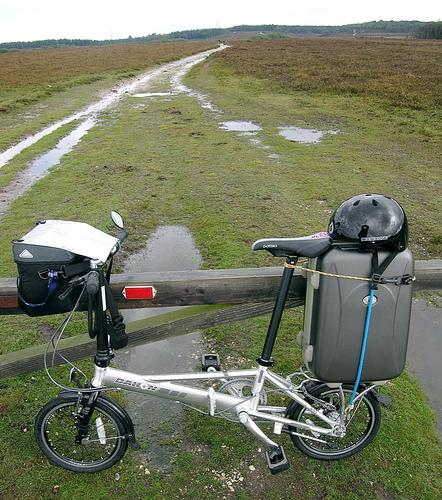Count how many bike wheels are present in the image and describe their positions. There are two bike wheels, the front wheel on the left and the back wheel on the right. Describe the image's sentiment or emotion. The image conveys a sense of wet, outdoor environment where one might have cycled on a rainy day and stopped to rest or park their bike. What type of helmet is on the bike, and where is it located? A black bike helmet rests on top of the bike, near its handlebars. What kind of fence is surrounding the bike, and what is the condition of the grass? It's a wooden fence, and the grass on the ground is damp and wet. What type of luggage is attached to the bicycle, and where is it located? A suitcase is attached to the back of the bike, and a black bike pouch is located near its handlebars. What is the primary object in the image, and what is its primary color? The primary object is a bike, and its primary color is silver. Identify any possible hazard or safety feature in the image. The white bike reflector is a safety feature, while the water puddle and damp grass could be potential hazards. Explain the role of the wooden fence in the image and what it's doing to the bike. The wooden fence serves as a support, with the bike tied to it to keep it from falling or being stolen. Assess the quality of the photograph, including the captured details and potential issues. The photograph captures various details like the bike, helmet, suitcase, fence, grass, and puddle. However, there could be slight clarity issues due to the presence of wet field and possible raindrops. Provide a detailed description of the bicycle's appearance and its surroundings. The silver bike has small tires, a black seat, and a basket attached to its handlebars. There's a black helmet on it and a suitcase on its back. It's tied to a wooden fence and surrounded by wet grass and a puddle under it. Identify the reflector on the fence. red reflector Can you see a suitcase in the image? If yes, where is it placed? Yes, it is attached to the back of the bike. Is there a large watermelon next to the wooden fence? There is no mention of a watermelon in the image. The only objects mentioned with the wooden fence are a bike, a suitcase, and wet grass. Which of these expressions best describes the image: "a peaceful winter landscape" or "an outdoor image featuring a bike"? an outdoor image featuring a bike What is the condition of the grass on the ground? Damp grass Is the bike in the image pink with purple stripes? There are multiple bikes mentioned in the image, but none of them are described as being pink with purple stripes. What is the color of the bike reflector? white What objects are attached to the bike's handlebars? a basket Does the bicycle have a blue and white striped umbrella attached to it? There is no mention of an umbrella in the image. The bike only has objects like a helmet, suitcase, basket, and pouch attached to it. Identify the water-related items in this scene. a small puddle under the bike, a water puddle, wet field, and damp grass What is the condition of the field in the image? Wet Field Which part of the bike is big? (A) Tires (B) Pedals (C) Seat (D) None (D) None Infer three significant object interactions in the image. 1. Bike tied to a fence Can you see a purple kite flying high above the trees in the background? There is no mention of a kite in the image. Background objects include trees, grass, and a fence. Describe the overall appearance of the bicycle. It is a silver bike with small tires, stacked with stuff, and has a basket attached to its handlebars. Describe the trees in the photo. trees visible behind the field Where is the helmet placed? on top of the bike Describe the state of the grass. green, damp, wet What is the color of the bike in the photo? Silver Give a short summary of the objects in the image. A silver bike tied to a wooden fence, with various items like a helmet, basket, suitcase, and pouch attached to it, surrounded by wet field and trees. Can you see water puddle in the image? Yes Identify the color of the wooden fence. The fence is not explicitly colored, but it appears to be a natural wooden color. Which object is attached to the bike handlebars? A basket How would you describe the current state of the grass? Green grass grows in a wet field. Is there a group of geese walking on the wet field in the image? There are no animals, specifically geese, mentioned in the image. The only elements related to the wet field are water puddles and grass. Is there a person riding one of the bikes while wearing a clown costume? There are no people mentioned in the image, let alone someone wearing a clown costume. 